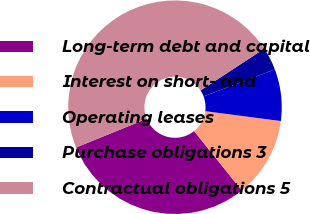Convert chart. <chart><loc_0><loc_0><loc_500><loc_500><pie_chart><fcel>Long-term debt and capital<fcel>Interest on short- and<fcel>Operating leases<fcel>Purchase obligations 3<fcel>Contractual obligations 5<nl><fcel>29.61%<fcel>12.17%<fcel>7.82%<fcel>3.48%<fcel>46.92%<nl></chart> 